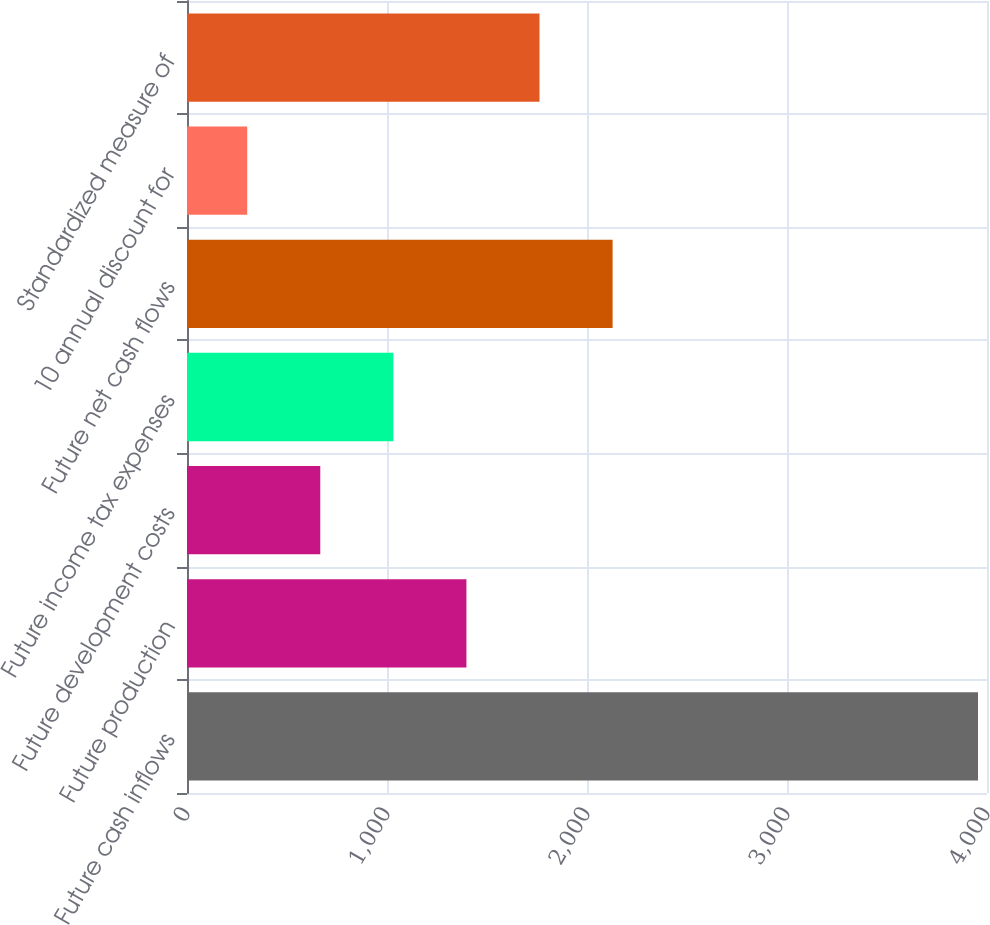Convert chart to OTSL. <chart><loc_0><loc_0><loc_500><loc_500><bar_chart><fcel>Future cash inflows<fcel>Future production<fcel>Future development costs<fcel>Future income tax expenses<fcel>Future net cash flows<fcel>10 annual discount for<fcel>Standardized measure of<nl><fcel>3955<fcel>1397.2<fcel>666.4<fcel>1031.8<fcel>2128<fcel>301<fcel>1762.6<nl></chart> 